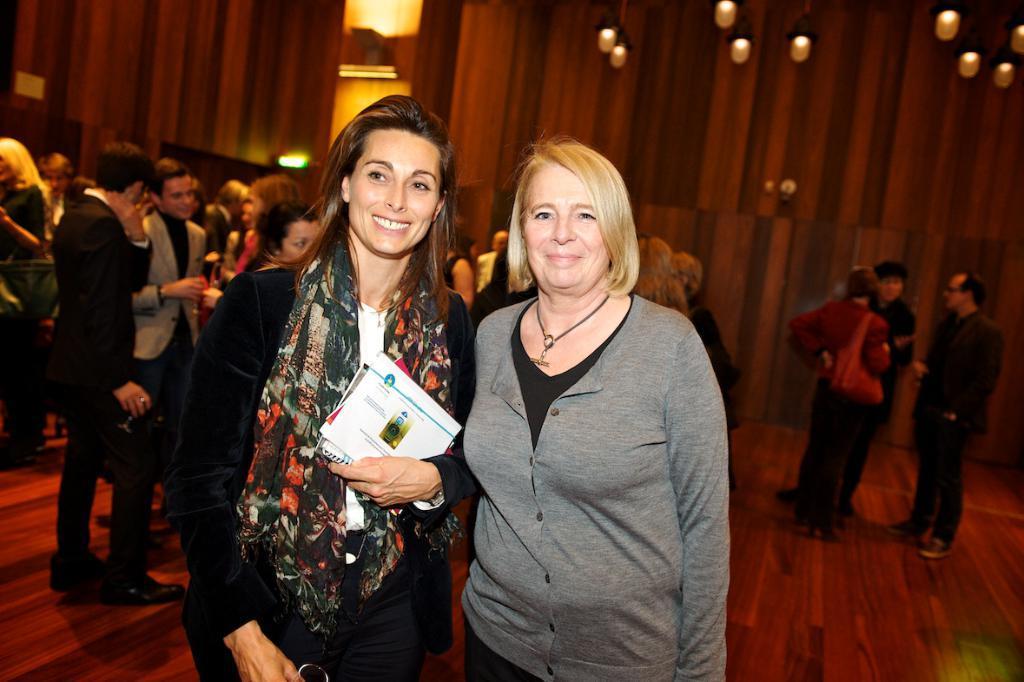Please provide a concise description of this image. In the center of the image we can see two ladies standing. The lady standing on the left is holding books in her hand. In the background there are people and wall. At the top there are lights. 